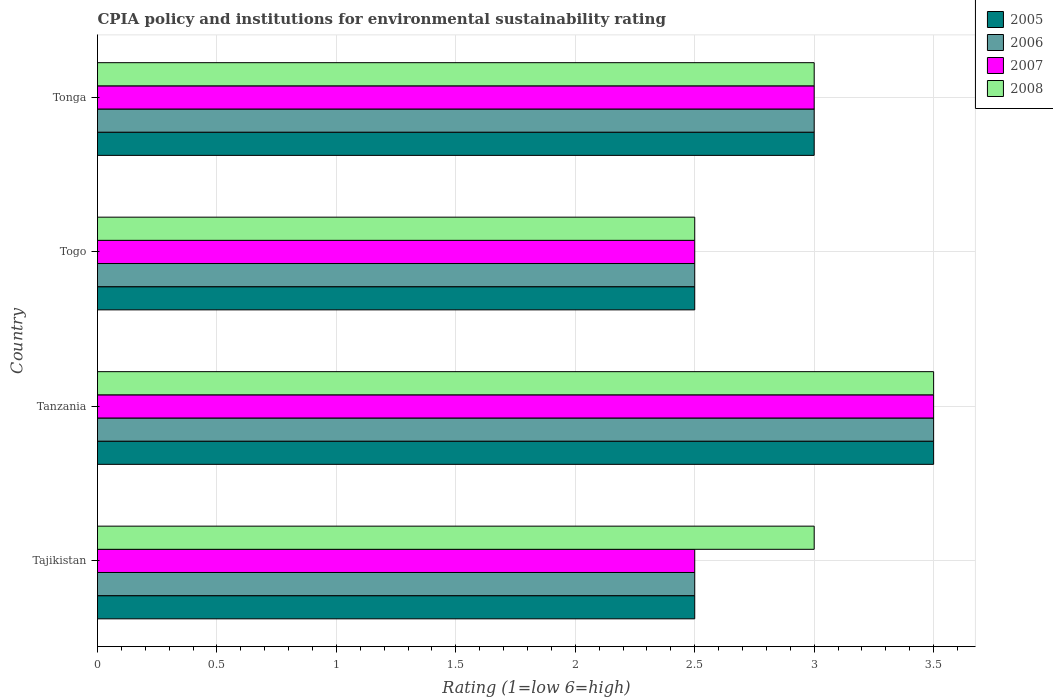How many different coloured bars are there?
Ensure brevity in your answer.  4. How many bars are there on the 1st tick from the top?
Provide a short and direct response. 4. What is the label of the 1st group of bars from the top?
Keep it short and to the point. Tonga. In how many cases, is the number of bars for a given country not equal to the number of legend labels?
Your answer should be very brief. 0. What is the CPIA rating in 2005 in Togo?
Your answer should be very brief. 2.5. Across all countries, what is the minimum CPIA rating in 2005?
Your response must be concise. 2.5. In which country was the CPIA rating in 2006 maximum?
Give a very brief answer. Tanzania. In which country was the CPIA rating in 2005 minimum?
Your answer should be very brief. Tajikistan. What is the average CPIA rating in 2006 per country?
Your answer should be very brief. 2.88. What is the difference between the CPIA rating in 2007 and CPIA rating in 2005 in Tanzania?
Offer a very short reply. 0. In how many countries, is the CPIA rating in 2007 greater than 1.3 ?
Offer a very short reply. 4. What is the ratio of the CPIA rating in 2008 in Tajikistan to that in Tanzania?
Offer a very short reply. 0.86. Is the difference between the CPIA rating in 2007 in Tanzania and Togo greater than the difference between the CPIA rating in 2005 in Tanzania and Togo?
Give a very brief answer. No. Is it the case that in every country, the sum of the CPIA rating in 2007 and CPIA rating in 2008 is greater than the CPIA rating in 2006?
Provide a succinct answer. Yes. How many countries are there in the graph?
Your answer should be compact. 4. Does the graph contain any zero values?
Offer a very short reply. No. Where does the legend appear in the graph?
Offer a terse response. Top right. How many legend labels are there?
Your answer should be compact. 4. How are the legend labels stacked?
Keep it short and to the point. Vertical. What is the title of the graph?
Give a very brief answer. CPIA policy and institutions for environmental sustainability rating. What is the Rating (1=low 6=high) of 2005 in Tajikistan?
Make the answer very short. 2.5. What is the Rating (1=low 6=high) of 2006 in Tajikistan?
Give a very brief answer. 2.5. What is the Rating (1=low 6=high) in 2008 in Tajikistan?
Your answer should be very brief. 3. What is the Rating (1=low 6=high) in 2006 in Tanzania?
Make the answer very short. 3.5. What is the Rating (1=low 6=high) in 2007 in Tanzania?
Give a very brief answer. 3.5. What is the Rating (1=low 6=high) of 2005 in Togo?
Your answer should be very brief. 2.5. What is the Rating (1=low 6=high) of 2005 in Tonga?
Your response must be concise. 3. What is the Rating (1=low 6=high) in 2006 in Tonga?
Provide a short and direct response. 3. What is the Rating (1=low 6=high) of 2007 in Tonga?
Keep it short and to the point. 3. Across all countries, what is the maximum Rating (1=low 6=high) in 2005?
Offer a terse response. 3.5. Across all countries, what is the maximum Rating (1=low 6=high) in 2007?
Your answer should be compact. 3.5. Across all countries, what is the maximum Rating (1=low 6=high) in 2008?
Provide a succinct answer. 3.5. Across all countries, what is the minimum Rating (1=low 6=high) of 2005?
Make the answer very short. 2.5. Across all countries, what is the minimum Rating (1=low 6=high) in 2006?
Offer a very short reply. 2.5. Across all countries, what is the minimum Rating (1=low 6=high) in 2008?
Your answer should be compact. 2.5. What is the total Rating (1=low 6=high) of 2005 in the graph?
Keep it short and to the point. 11.5. What is the total Rating (1=low 6=high) in 2006 in the graph?
Make the answer very short. 11.5. What is the total Rating (1=low 6=high) of 2007 in the graph?
Provide a short and direct response. 11.5. What is the difference between the Rating (1=low 6=high) in 2008 in Tajikistan and that in Tanzania?
Your answer should be very brief. -0.5. What is the difference between the Rating (1=low 6=high) in 2005 in Tajikistan and that in Togo?
Your response must be concise. 0. What is the difference between the Rating (1=low 6=high) in 2006 in Tajikistan and that in Togo?
Your answer should be very brief. 0. What is the difference between the Rating (1=low 6=high) in 2008 in Tajikistan and that in Togo?
Give a very brief answer. 0.5. What is the difference between the Rating (1=low 6=high) in 2005 in Tajikistan and that in Tonga?
Your answer should be compact. -0.5. What is the difference between the Rating (1=low 6=high) in 2007 in Tajikistan and that in Tonga?
Give a very brief answer. -0.5. What is the difference between the Rating (1=low 6=high) of 2005 in Tanzania and that in Togo?
Your answer should be very brief. 1. What is the difference between the Rating (1=low 6=high) in 2007 in Tanzania and that in Togo?
Ensure brevity in your answer.  1. What is the difference between the Rating (1=low 6=high) of 2006 in Togo and that in Tonga?
Make the answer very short. -0.5. What is the difference between the Rating (1=low 6=high) in 2007 in Togo and that in Tonga?
Your answer should be compact. -0.5. What is the difference between the Rating (1=low 6=high) of 2008 in Togo and that in Tonga?
Ensure brevity in your answer.  -0.5. What is the difference between the Rating (1=low 6=high) of 2005 in Tajikistan and the Rating (1=low 6=high) of 2007 in Tanzania?
Provide a short and direct response. -1. What is the difference between the Rating (1=low 6=high) of 2005 in Tajikistan and the Rating (1=low 6=high) of 2008 in Tanzania?
Keep it short and to the point. -1. What is the difference between the Rating (1=low 6=high) in 2006 in Tajikistan and the Rating (1=low 6=high) in 2007 in Tanzania?
Your response must be concise. -1. What is the difference between the Rating (1=low 6=high) in 2006 in Tajikistan and the Rating (1=low 6=high) in 2008 in Tanzania?
Offer a very short reply. -1. What is the difference between the Rating (1=low 6=high) in 2007 in Tajikistan and the Rating (1=low 6=high) in 2008 in Togo?
Keep it short and to the point. 0. What is the difference between the Rating (1=low 6=high) in 2005 in Tajikistan and the Rating (1=low 6=high) in 2006 in Tonga?
Give a very brief answer. -0.5. What is the difference between the Rating (1=low 6=high) in 2007 in Tajikistan and the Rating (1=low 6=high) in 2008 in Tonga?
Offer a very short reply. -0.5. What is the difference between the Rating (1=low 6=high) of 2005 in Tanzania and the Rating (1=low 6=high) of 2006 in Togo?
Offer a very short reply. 1. What is the difference between the Rating (1=low 6=high) in 2006 in Tanzania and the Rating (1=low 6=high) in 2008 in Togo?
Keep it short and to the point. 1. What is the difference between the Rating (1=low 6=high) in 2007 in Tanzania and the Rating (1=low 6=high) in 2008 in Togo?
Make the answer very short. 1. What is the difference between the Rating (1=low 6=high) of 2005 in Tanzania and the Rating (1=low 6=high) of 2007 in Tonga?
Offer a terse response. 0.5. What is the difference between the Rating (1=low 6=high) in 2005 in Tanzania and the Rating (1=low 6=high) in 2008 in Tonga?
Offer a terse response. 0.5. What is the difference between the Rating (1=low 6=high) of 2006 in Tanzania and the Rating (1=low 6=high) of 2007 in Tonga?
Ensure brevity in your answer.  0.5. What is the difference between the Rating (1=low 6=high) in 2006 in Tanzania and the Rating (1=low 6=high) in 2008 in Tonga?
Offer a terse response. 0.5. What is the difference between the Rating (1=low 6=high) of 2007 in Tanzania and the Rating (1=low 6=high) of 2008 in Tonga?
Your answer should be compact. 0.5. What is the difference between the Rating (1=low 6=high) in 2005 in Togo and the Rating (1=low 6=high) in 2007 in Tonga?
Offer a very short reply. -0.5. What is the difference between the Rating (1=low 6=high) of 2005 in Togo and the Rating (1=low 6=high) of 2008 in Tonga?
Keep it short and to the point. -0.5. What is the difference between the Rating (1=low 6=high) in 2006 in Togo and the Rating (1=low 6=high) in 2007 in Tonga?
Your answer should be compact. -0.5. What is the difference between the Rating (1=low 6=high) in 2006 in Togo and the Rating (1=low 6=high) in 2008 in Tonga?
Make the answer very short. -0.5. What is the average Rating (1=low 6=high) in 2005 per country?
Provide a succinct answer. 2.88. What is the average Rating (1=low 6=high) of 2006 per country?
Make the answer very short. 2.88. What is the average Rating (1=low 6=high) in 2007 per country?
Provide a succinct answer. 2.88. What is the average Rating (1=low 6=high) in 2008 per country?
Make the answer very short. 3. What is the difference between the Rating (1=low 6=high) of 2005 and Rating (1=low 6=high) of 2006 in Tajikistan?
Make the answer very short. 0. What is the difference between the Rating (1=low 6=high) in 2006 and Rating (1=low 6=high) in 2008 in Tajikistan?
Make the answer very short. -0.5. What is the difference between the Rating (1=low 6=high) of 2007 and Rating (1=low 6=high) of 2008 in Tajikistan?
Give a very brief answer. -0.5. What is the difference between the Rating (1=low 6=high) in 2006 and Rating (1=low 6=high) in 2007 in Tanzania?
Give a very brief answer. 0. What is the difference between the Rating (1=low 6=high) in 2006 and Rating (1=low 6=high) in 2008 in Tanzania?
Offer a terse response. 0. What is the difference between the Rating (1=low 6=high) in 2005 and Rating (1=low 6=high) in 2007 in Togo?
Keep it short and to the point. 0. What is the difference between the Rating (1=low 6=high) of 2006 and Rating (1=low 6=high) of 2008 in Togo?
Your answer should be very brief. 0. What is the difference between the Rating (1=low 6=high) in 2005 and Rating (1=low 6=high) in 2006 in Tonga?
Provide a short and direct response. 0. What is the difference between the Rating (1=low 6=high) of 2006 and Rating (1=low 6=high) of 2008 in Tonga?
Give a very brief answer. 0. What is the difference between the Rating (1=low 6=high) of 2007 and Rating (1=low 6=high) of 2008 in Tonga?
Provide a short and direct response. 0. What is the ratio of the Rating (1=low 6=high) in 2007 in Tajikistan to that in Tanzania?
Offer a very short reply. 0.71. What is the ratio of the Rating (1=low 6=high) in 2008 in Tajikistan to that in Tanzania?
Offer a very short reply. 0.86. What is the ratio of the Rating (1=low 6=high) of 2005 in Tajikistan to that in Togo?
Your answer should be very brief. 1. What is the ratio of the Rating (1=low 6=high) of 2007 in Tajikistan to that in Togo?
Offer a terse response. 1. What is the ratio of the Rating (1=low 6=high) in 2008 in Tajikistan to that in Togo?
Keep it short and to the point. 1.2. What is the ratio of the Rating (1=low 6=high) of 2007 in Tajikistan to that in Tonga?
Provide a short and direct response. 0.83. What is the ratio of the Rating (1=low 6=high) in 2008 in Tajikistan to that in Tonga?
Make the answer very short. 1. What is the ratio of the Rating (1=low 6=high) of 2008 in Tanzania to that in Togo?
Make the answer very short. 1.4. What is the ratio of the Rating (1=low 6=high) in 2005 in Togo to that in Tonga?
Your answer should be very brief. 0.83. What is the ratio of the Rating (1=low 6=high) in 2007 in Togo to that in Tonga?
Your answer should be compact. 0.83. What is the difference between the highest and the lowest Rating (1=low 6=high) of 2005?
Keep it short and to the point. 1. What is the difference between the highest and the lowest Rating (1=low 6=high) in 2006?
Your answer should be compact. 1. What is the difference between the highest and the lowest Rating (1=low 6=high) in 2007?
Offer a terse response. 1. What is the difference between the highest and the lowest Rating (1=low 6=high) in 2008?
Your answer should be compact. 1. 